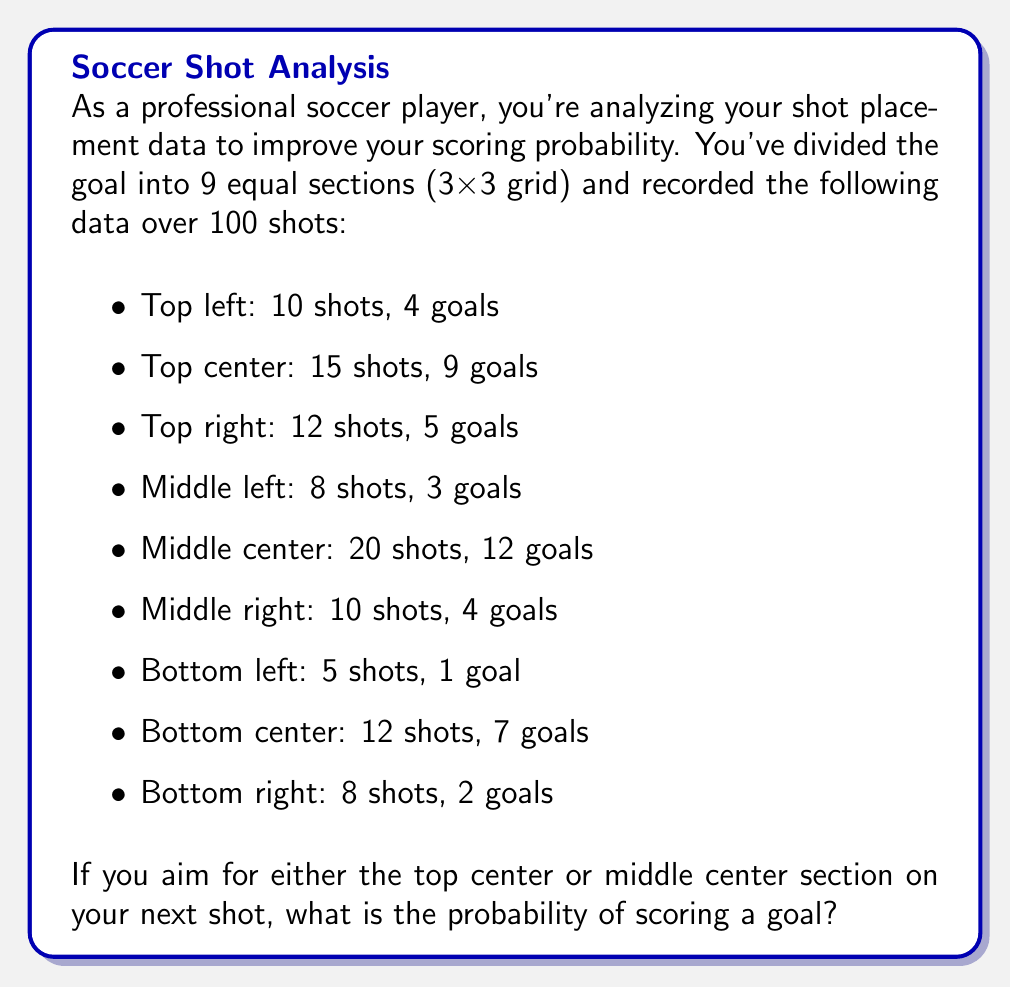Can you solve this math problem? To solve this problem, we need to follow these steps:

1) First, let's identify the relevant sections: top center and middle center.

2) For the top center:
   - Total shots: 15
   - Goals scored: 9
   - Probability = $\frac{9}{15} = 0.6$ or 60%

3) For the middle center:
   - Total shots: 20
   - Goals scored: 12
   - Probability = $\frac{12}{20} = 0.6$ or 60%

4) Now, we need to calculate the combined probability of scoring if aiming for either of these sections. This is a case of mutually exclusive events (the shot can only go to one section), so we add the individual probabilities.

5) However, we need to account for the likelihood of the shot going to each section. We can use the given data to calculate this:

   - Probability of shot going to top center = $\frac{15}{35} = \frac{3}{7}$
   - Probability of shot going to middle center = $\frac{20}{35} = \frac{4}{7}$

6) Now we can calculate the total probability:

   $$P(\text{scoring}) = P(\text{top center}) \cdot P(\text{scoring | top center}) + P(\text{middle center}) \cdot P(\text{scoring | middle center})$$

   $$P(\text{scoring}) = \frac{3}{7} \cdot 0.6 + \frac{4}{7} \cdot 0.6$$

   $$P(\text{scoring}) = 0.6 \cdot (\frac{3}{7} + \frac{4}{7}) = 0.6 \cdot 1 = 0.6$$

Therefore, the probability of scoring when aiming for either the top center or middle center is 0.6 or 60%.
Answer: 0.6 or 60% 